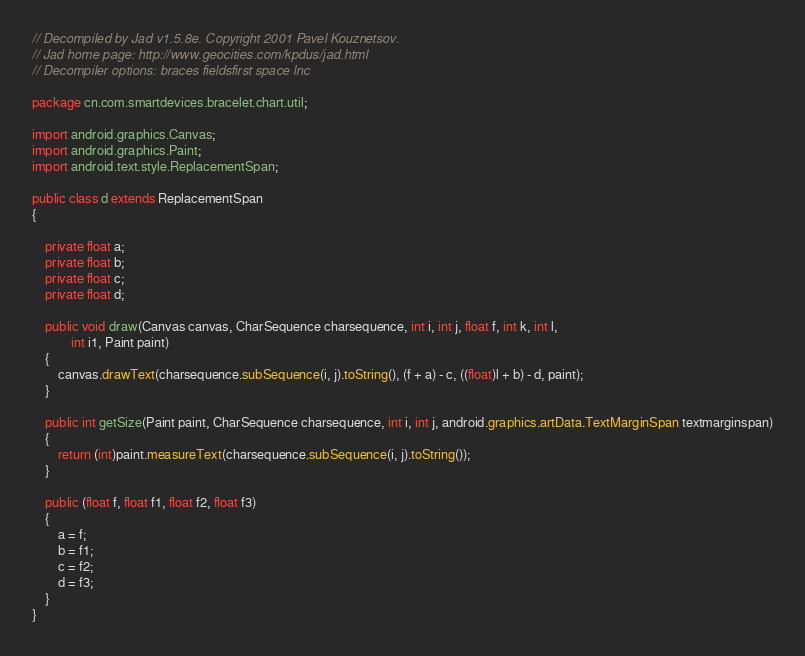Convert code to text. <code><loc_0><loc_0><loc_500><loc_500><_Java_>// Decompiled by Jad v1.5.8e. Copyright 2001 Pavel Kouznetsov.
// Jad home page: http://www.geocities.com/kpdus/jad.html
// Decompiler options: braces fieldsfirst space lnc 

package cn.com.smartdevices.bracelet.chart.util;

import android.graphics.Canvas;
import android.graphics.Paint;
import android.text.style.ReplacementSpan;

public class d extends ReplacementSpan
{

    private float a;
    private float b;
    private float c;
    private float d;

    public void draw(Canvas canvas, CharSequence charsequence, int i, int j, float f, int k, int l, 
            int i1, Paint paint)
    {
        canvas.drawText(charsequence.subSequence(i, j).toString(), (f + a) - c, ((float)l + b) - d, paint);
    }

    public int getSize(Paint paint, CharSequence charsequence, int i, int j, android.graphics.artData.TextMarginSpan textmarginspan)
    {
        return (int)paint.measureText(charsequence.subSequence(i, j).toString());
    }

    public (float f, float f1, float f2, float f3)
    {
        a = f;
        b = f1;
        c = f2;
        d = f3;
    }
}
</code> 